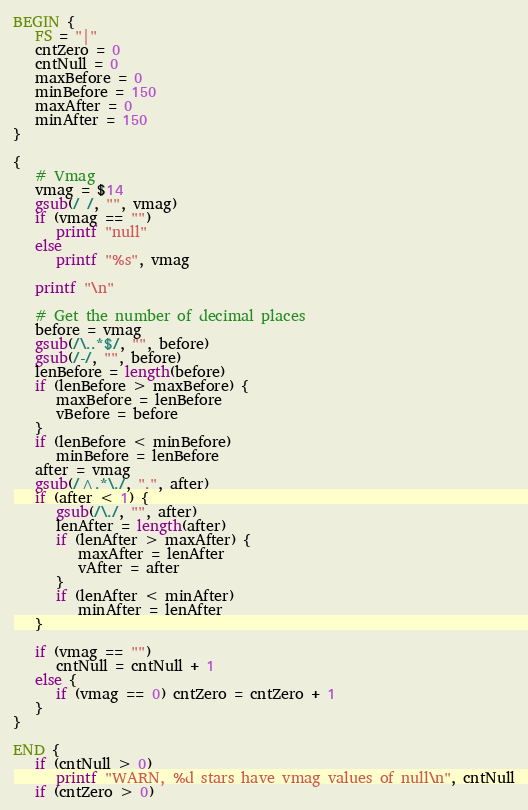Convert code to text. <code><loc_0><loc_0><loc_500><loc_500><_Awk_>BEGIN {
   FS = "|"
   cntZero = 0
   cntNull = 0
   maxBefore = 0
   minBefore = 150
   maxAfter = 0
   minAfter = 150
}

{ 
   # Vmag
   vmag = $14
   gsub(/ /, "", vmag)
   if (vmag == "")
      printf "null"
   else     
      printf "%s", vmag

   printf "\n"

   # Get the number of decimal places
   before = vmag
   gsub(/\..*$/, "", before)
   gsub(/-/, "", before)
   lenBefore = length(before)
   if (lenBefore > maxBefore) {
      maxBefore = lenBefore
      vBefore = before
   }
   if (lenBefore < minBefore)
      minBefore = lenBefore
   after = vmag
   gsub(/^.*\./, ".", after)
   if (after < 1) {
      gsub(/\./, "", after)
      lenAfter = length(after)
      if (lenAfter > maxAfter) {
         maxAfter = lenAfter
         vAfter = after
      }
      if (lenAfter < minAfter)
         minAfter = lenAfter
   }

   if (vmag == "")
      cntNull = cntNull + 1
   else {
      if (vmag == 0) cntZero = cntZero + 1
   }
}

END {
   if (cntNull > 0)
      printf "WARN, %d stars have vmag values of null\n", cntNull
   if (cntZero > 0)</code> 